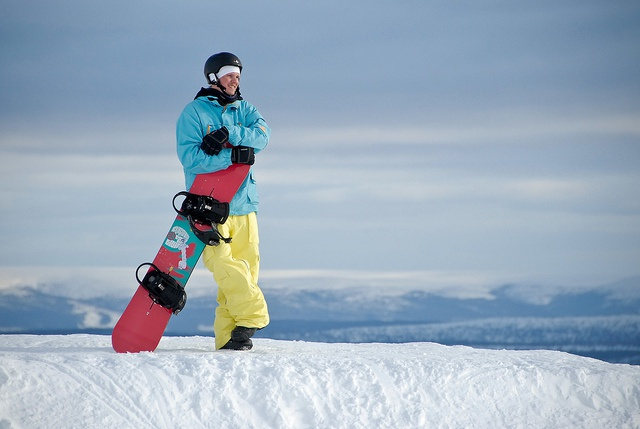Describe the objects in this image and their specific colors. I can see people in gray, black, khaki, and teal tones and snowboard in gray, brown, black, and teal tones in this image. 